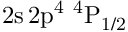Convert formula to latex. <formula><loc_0><loc_0><loc_500><loc_500>2 s \, 2 p ^ { 4 } ^ { 4 } P _ { 1 / 2 }</formula> 